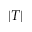Convert formula to latex. <formula><loc_0><loc_0><loc_500><loc_500>| T |</formula> 